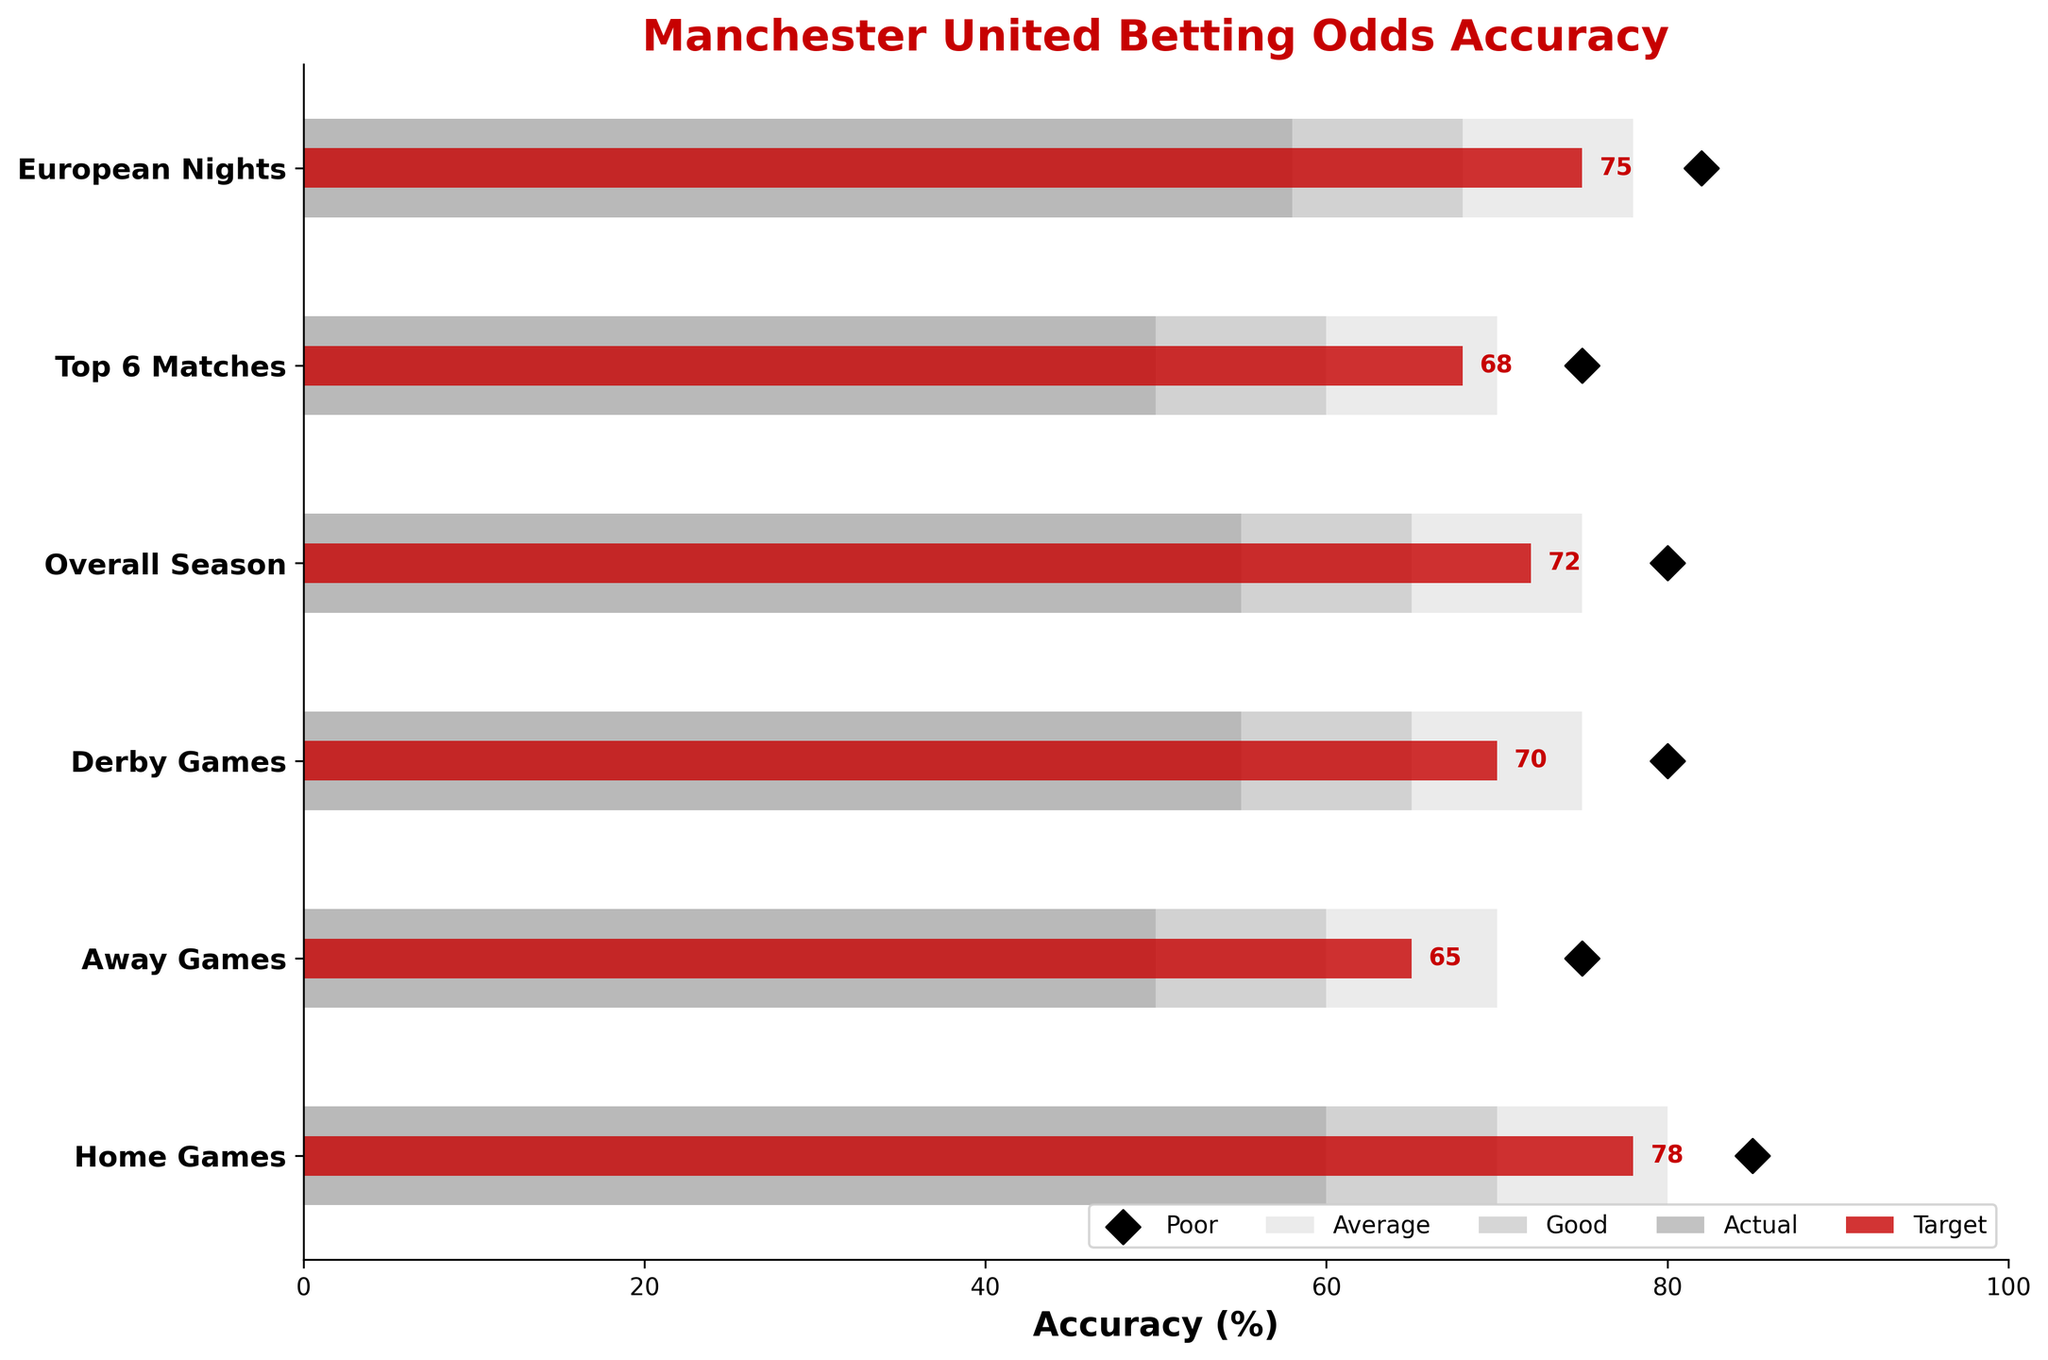How many categories are represented in the plot? There are labels displayed on the y-axis of the plot, indicating the different categories represented. By counting these labels, we see six categories.
Answer: Six What is the title of the figure? The title of the figure is displayed prominently at the top. By looking at this text, we see the title reads "Manchester United Betting Odds Accuracy.”
Answer: Manchester United Betting Odds Accuracy Which category has the highest actual value? By inspecting the red bars in the plot, which represent the actual values, we find that the "Home Games" category has the longest red bar, indicating the highest actual value.
Answer: Home Games What is the target value for "European Nights"? By locating the "European Nights" category and then finding the black diamond marker that represents the target value, we see it is positioned at 82.
Answer: 82 How do the actual values compare in "Away Games" and "Derby Games"? The actual value for "Away Games," represented by the red bar, is at 65, whereas for "Derby Games," it is at 70. By comparing these two numbers, we see that the actual value for "Derby Games" is higher than that for "Away Games."
Answer: Derby Games is higher What is the average target value across all categories? We sum the target values of all categories: 85, 75, 80, 80, 75, and 82. Their total is 477, and dividing by the number of categories (6) gives an average target value of 79.5.
Answer: 79.5 Which category has the smallest difference between actual and target values? We calculate the difference for each category by subtracting the actual values from the target values: 
  - Home Games: 85 - 78 = 7 
  - Away Games: 75 - 65 = 10 
  - Derby Games: 80 - 70 = 10 
  - Overall Season: 80 - 72 = 8 
  - Top 6 Matches: 75 - 68 = 7 
  - European Nights: 82 - 75 = 7. 
  Home Games, Top 6 Matches, and European Nights all have the smallest difference of 7.
Answer: Home Games, Top 6 Matches, European Nights Which has a higher actual value: "Top 6 Matches" or "European Nights"? By how much? The actual value for "Top 6 Matches" is 68, and for "European Nights," it is 75. Subtracting these values (75 - 68), we find that "European Nights" has a higher actual value by 7.
Answer: European Nights by 7 Are all actual values within their respective range3 thresholds? We compare each actual value to the upper limit of their range3: 
  - Home Games: 78 (within 80) 
  - Away Games: 65 (within 70) 
  - Derby Games: 70 (within 75) 
  - Overall Season: 72 (within 75) 
  - Top 6 Matches: 68 (within 70) 
  - European Nights: 75 (within 78). 
  All actual values fall within their range3 thresholds.
Answer: Yes 